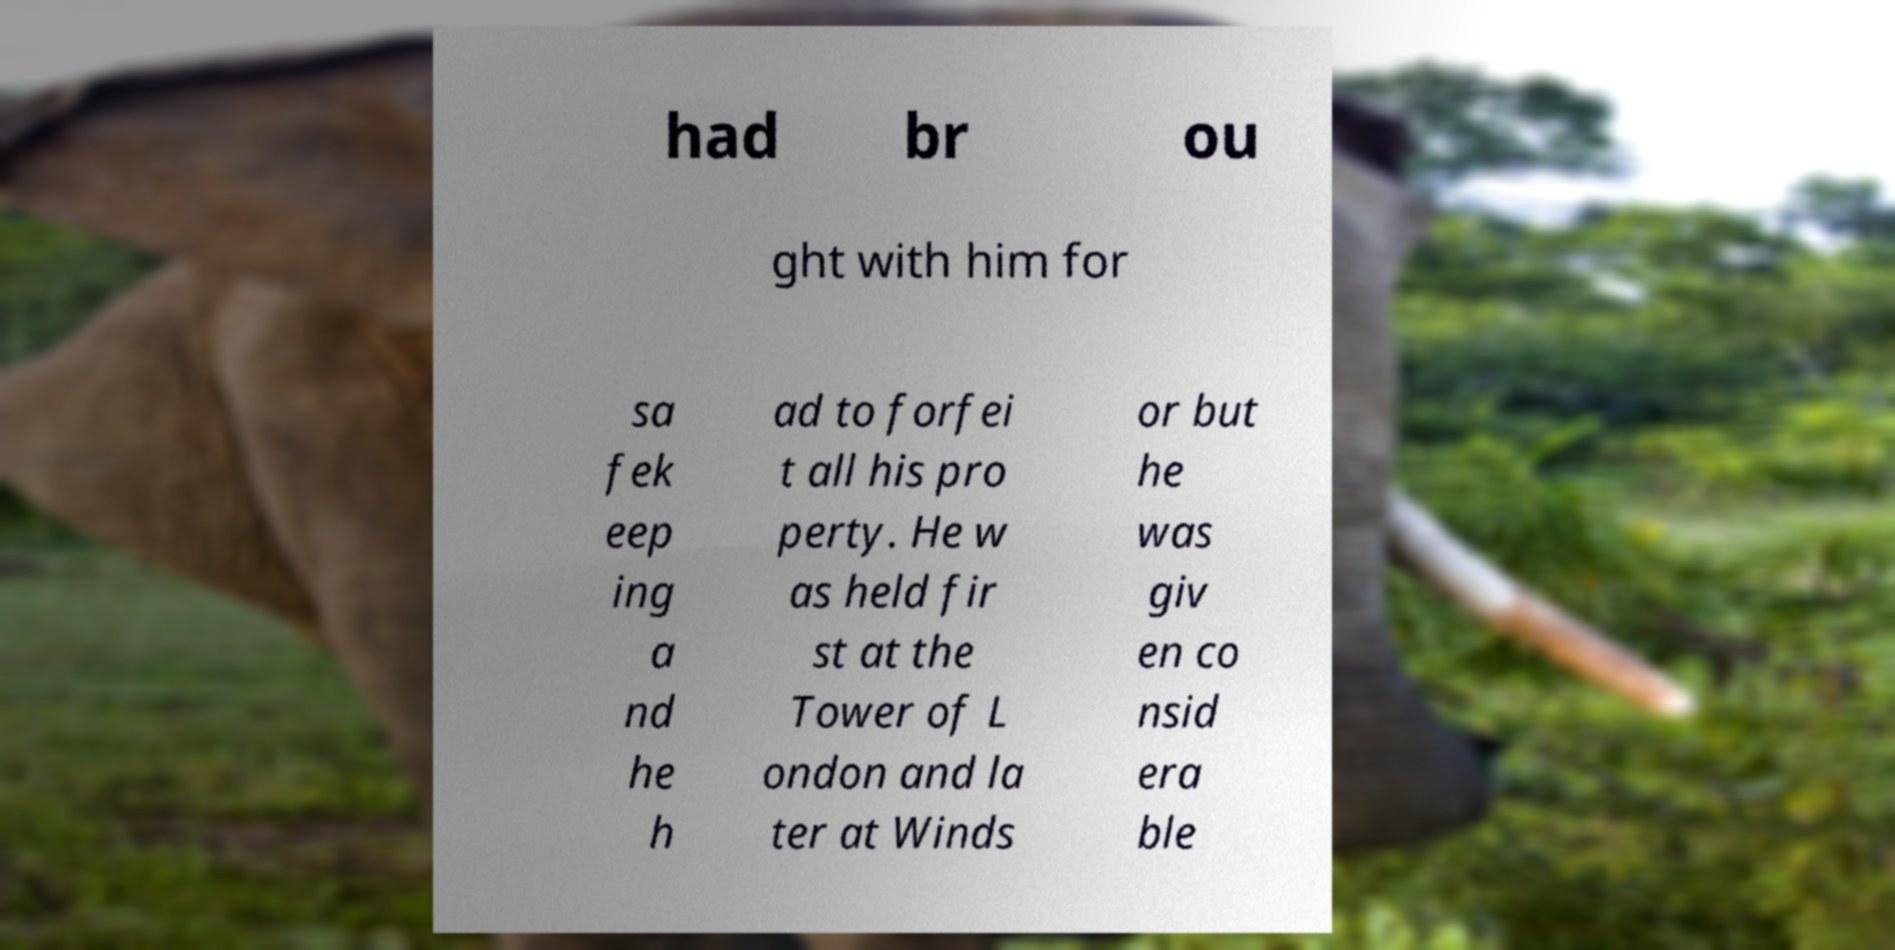There's text embedded in this image that I need extracted. Can you transcribe it verbatim? had br ou ght with him for sa fek eep ing a nd he h ad to forfei t all his pro perty. He w as held fir st at the Tower of L ondon and la ter at Winds or but he was giv en co nsid era ble 